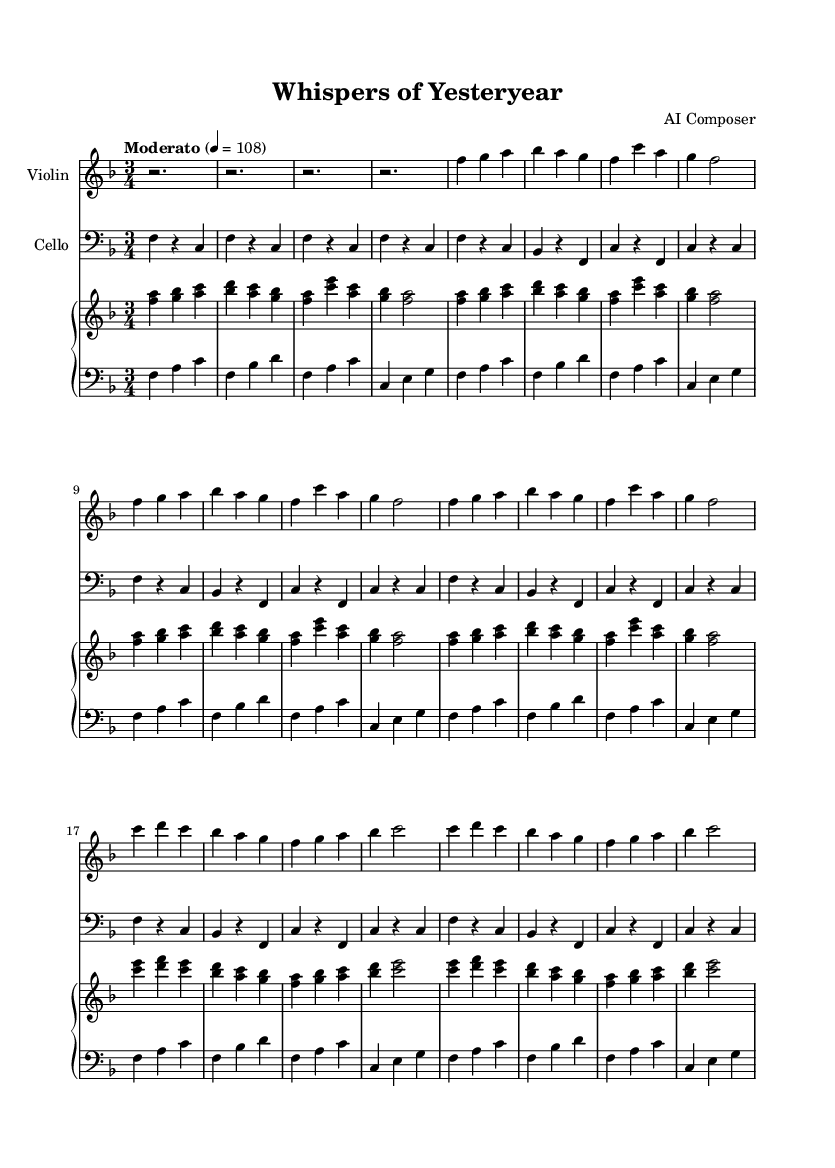What is the key signature of this music? The key signature shows one flat (B♭), indicating that the music is in F major.
Answer: F major What is the time signature of this piece? The time signature is indicated by the number of beats per measure and is displayed at the beginning of the sheet music as 3/4, meaning there are three beats in each measure and a quarter note receives one beat.
Answer: 3/4 What is the tempo indication for this piece? The tempo indication states "Moderato" with a metronome marking of 108, which suggests a moderate speed for the performance of the piece.
Answer: Moderate 4 = 108 What is the total number of measures in the A section? The A section consists of three groups of eight measures (one complete section), totaling 24 measures, which are easily counted as separate musical phrases are visible on the sheet.
Answer: 24 How many instruments are indicated in the score? The score shows the presence of four distinct systems, two for the piano (upper and lower), one for the violin, and one for the cello, indicating a total of four instruments.
Answer: Four What is the highest pitch note in the violin part? By examining the notes on the staff for the violin, the highest pitch note reached is A5, specifically at the beginning of the second measure in the second line of the A section.
Answer: A5 In which section does the melody change noticeably? The B section of the piece, starting after the first A section, introduces a different melody with a notable transition, indicating a departure from the A section themes.
Answer: B section 